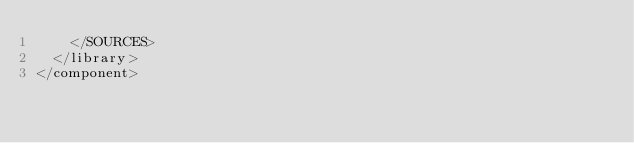<code> <loc_0><loc_0><loc_500><loc_500><_XML_>    </SOURCES>
  </library>
</component></code> 